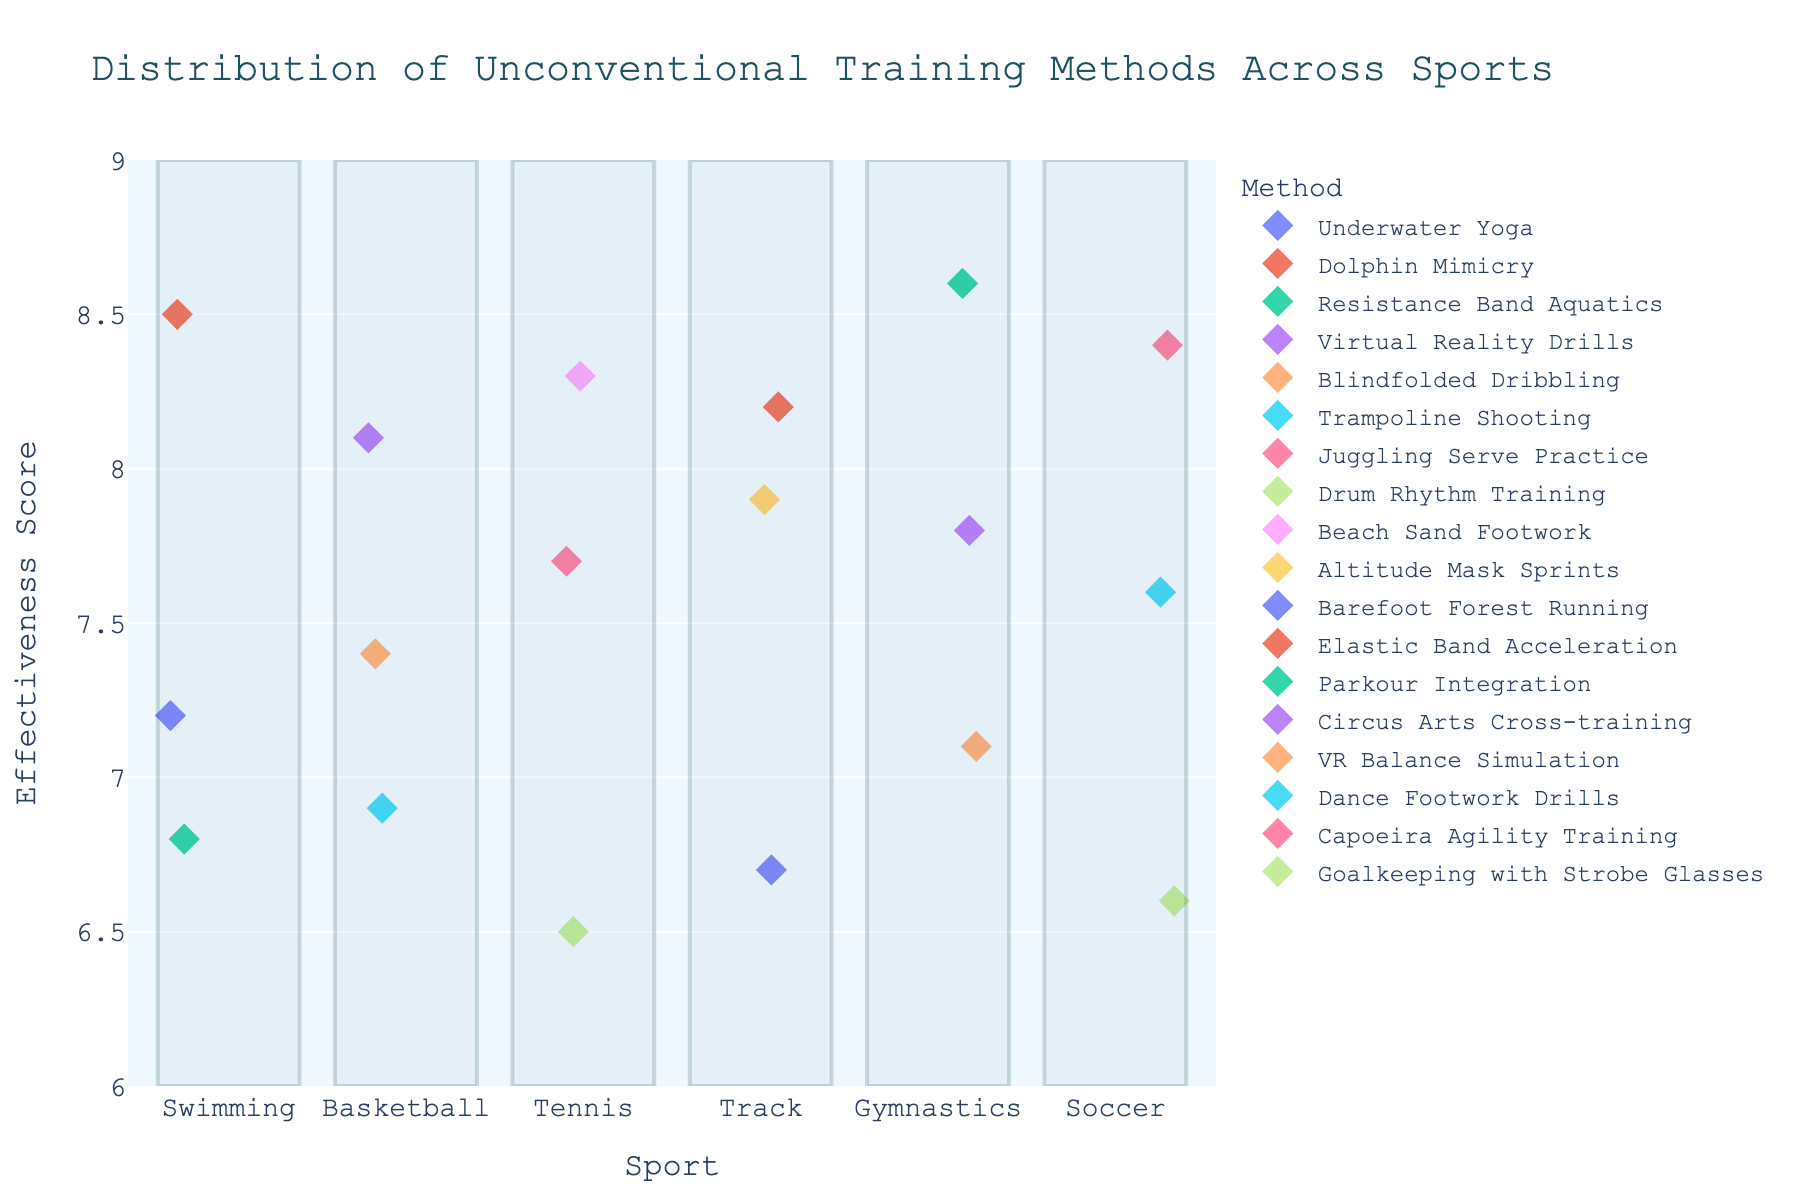What's the title of the plot? The title is usually placed at the top of the plot and is designed to describe what the plot is about.
Answer: Distribution of Unconventional Training Methods Across Sports What is the highest effectiveness score in Gymnastics? Look for the data points above the "Gymnastics" label on the x-axis and find the one with the highest y-value.
Answer: 8.6 Which sport has the method "Dolphin Mimicry," and what is its effectiveness score? Identify the point labeled “Dolphin Mimicry” and follow the x-axis to determine the sport, then read the y-axis value for effectiveness.
Answer: Swimming, 8.5 How many methods have an effectiveness score above 8.0 in Tennis? Look at the points above "Tennis" on the x-axis and count those where the y-value is greater than 8.0. There are two points: "Beach Sand Footwork" (8.3) and "Juggling Serve Practice" (7.7 → less than 8.0, hence incorrect). Only one method "Beach Sand Footwork" remains.
Answer: 1 What’s the average effectiveness score for Basketball? Extract the y-values of the points above "Basketball" which are 8.1, 7.4, and 6.9. Calculate the average: (8.1 + 7.4 + 6.9) / 3 ≈ 7.47
Answer: ~7.47 Which training method in Soccer has the lowest effectiveness score, and what is the score? Check the points above "Soccer" and identify the one with the lowest y-value.
Answer: Goalkeeping with Strobe Glasses, 6.6 Compare the effectiveness between "Altitude Mask Sprints" in Track and "Juggling Serve Practice" in Tennis. Which is higher? Identify the y-values for "Altitude Mask Sprints" (7.9) and "Juggling Serve Practice" (7.7), then compare.
Answer: Altitude Mask Sprints List the sports that utilize Virtual Reality (VR) in their training methods. Look for all methods related to VR and track the associated sports using the x-axis labels. "Virtual Reality Drills" is in Basketball and "VR Balance Simulation" in Gymnastics.
Answer: Basketball, Gymnastics What rectangular filled area looks light blue in the plot? By examining the plot, we see rectangular shapes filled with a light blue color surrounding each sport label. These areas help highlight the data points category-wise.
Answer: Area around each sport on the x-axis What's the range of effectiveness scores used in the y-axis? Check the labeled tick marks on the y-axis. The range starts from 6 and goes up to 9, with tick marks every 0.5 intervals.
Answer: 6 to 9 